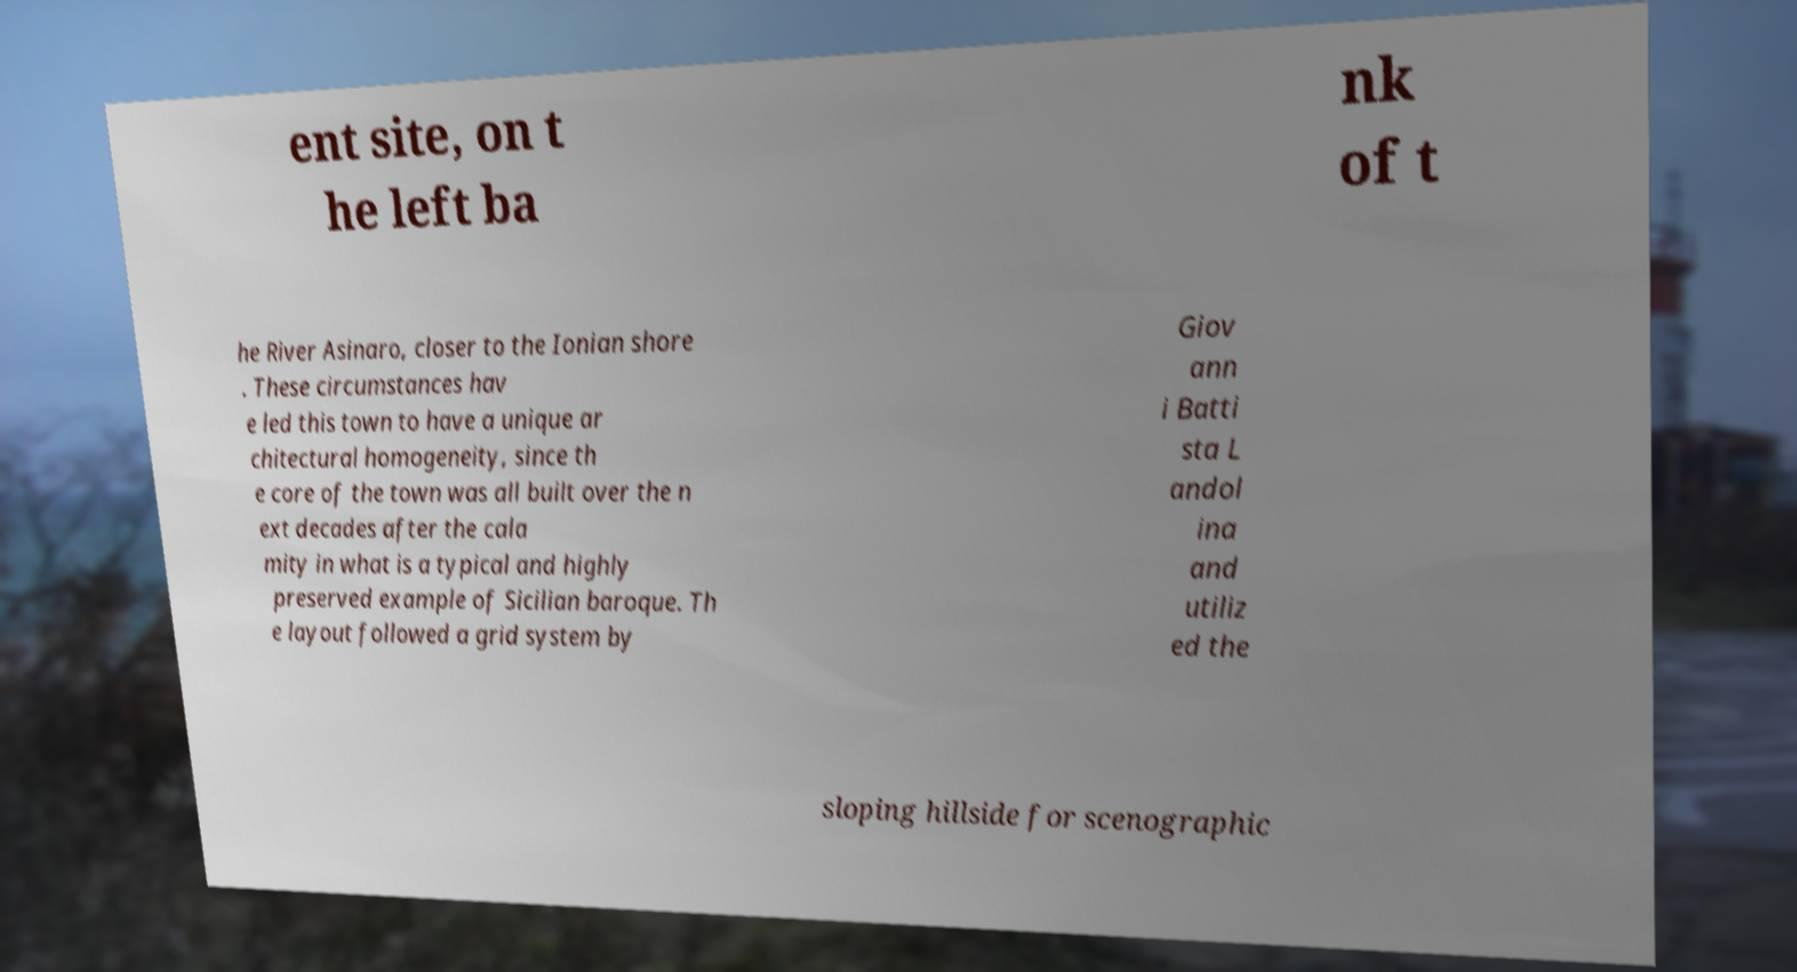I need the written content from this picture converted into text. Can you do that? ent site, on t he left ba nk of t he River Asinaro, closer to the Ionian shore . These circumstances hav e led this town to have a unique ar chitectural homogeneity, since th e core of the town was all built over the n ext decades after the cala mity in what is a typical and highly preserved example of Sicilian baroque. Th e layout followed a grid system by Giov ann i Batti sta L andol ina and utiliz ed the sloping hillside for scenographic 